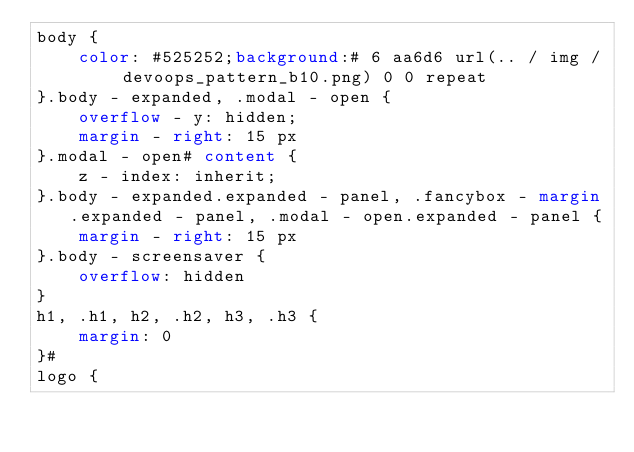<code> <loc_0><loc_0><loc_500><loc_500><_CSS_>body {
    color: #525252;background:# 6 aa6d6 url(.. / img / devoops_pattern_b10.png) 0 0 repeat
}.body - expanded, .modal - open {
    overflow - y: hidden;
    margin - right: 15 px
}.modal - open# content {
    z - index: inherit;
}.body - expanded.expanded - panel, .fancybox - margin.expanded - panel, .modal - open.expanded - panel {
    margin - right: 15 px
}.body - screensaver {
    overflow: hidden
}
h1, .h1, h2, .h2, h3, .h3 {
    margin: 0
}#
logo {</code> 